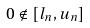Convert formula to latex. <formula><loc_0><loc_0><loc_500><loc_500>0 \notin [ l _ { n } , u _ { n } ]</formula> 